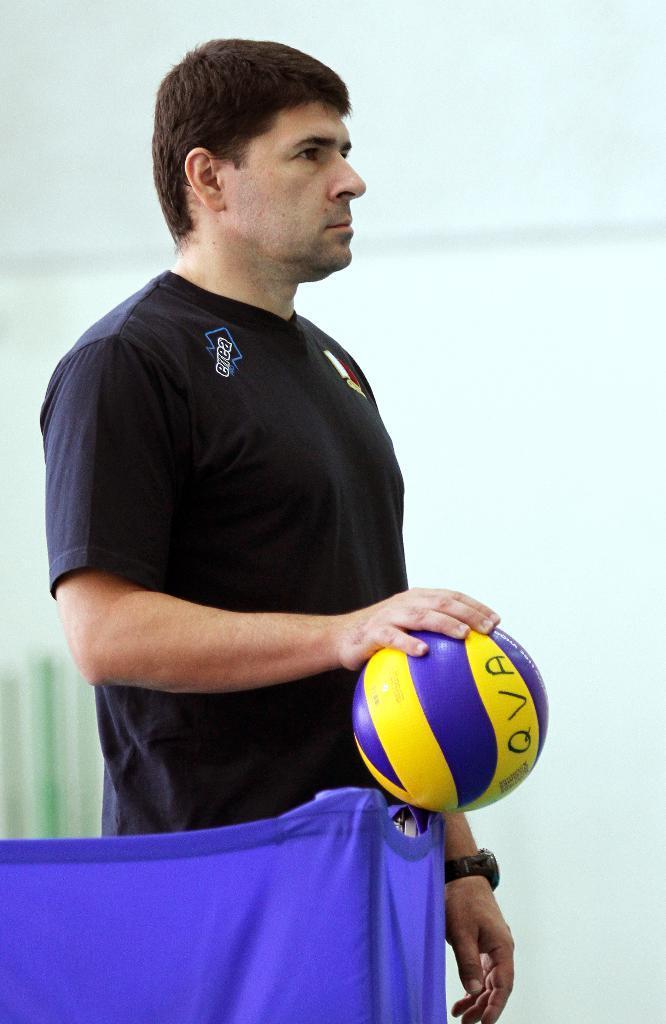Describe this image in one or two sentences. In this picture there is a man who is wearing t-shirt and watch. He is holding a volleyball. In the bottom left I can see the blue cloth. In the back I can see the blur image. 